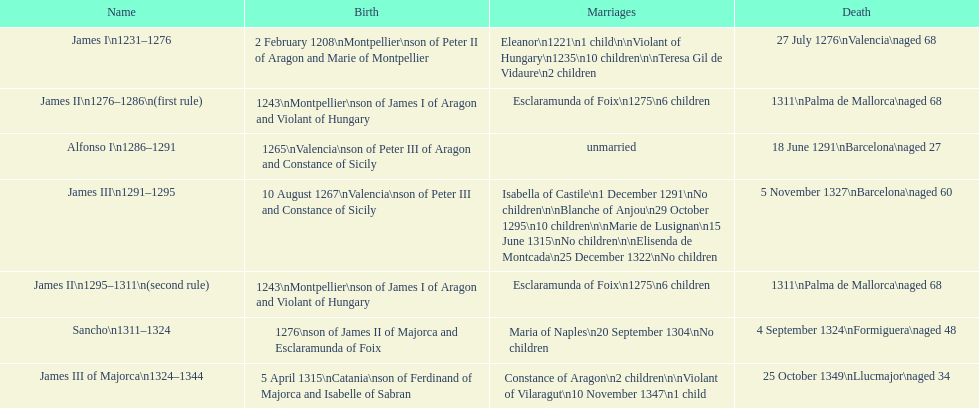Was james iii or sancho birthed in the year 1276? Sancho. 